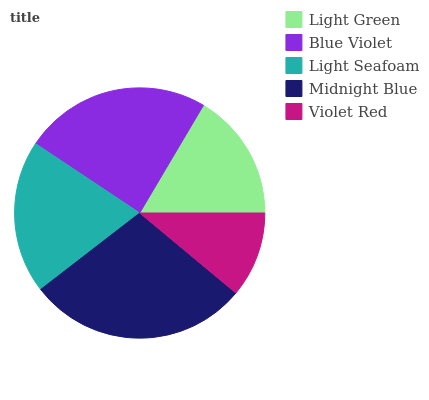Is Violet Red the minimum?
Answer yes or no. Yes. Is Midnight Blue the maximum?
Answer yes or no. Yes. Is Blue Violet the minimum?
Answer yes or no. No. Is Blue Violet the maximum?
Answer yes or no. No. Is Blue Violet greater than Light Green?
Answer yes or no. Yes. Is Light Green less than Blue Violet?
Answer yes or no. Yes. Is Light Green greater than Blue Violet?
Answer yes or no. No. Is Blue Violet less than Light Green?
Answer yes or no. No. Is Light Seafoam the high median?
Answer yes or no. Yes. Is Light Seafoam the low median?
Answer yes or no. Yes. Is Midnight Blue the high median?
Answer yes or no. No. Is Blue Violet the low median?
Answer yes or no. No. 